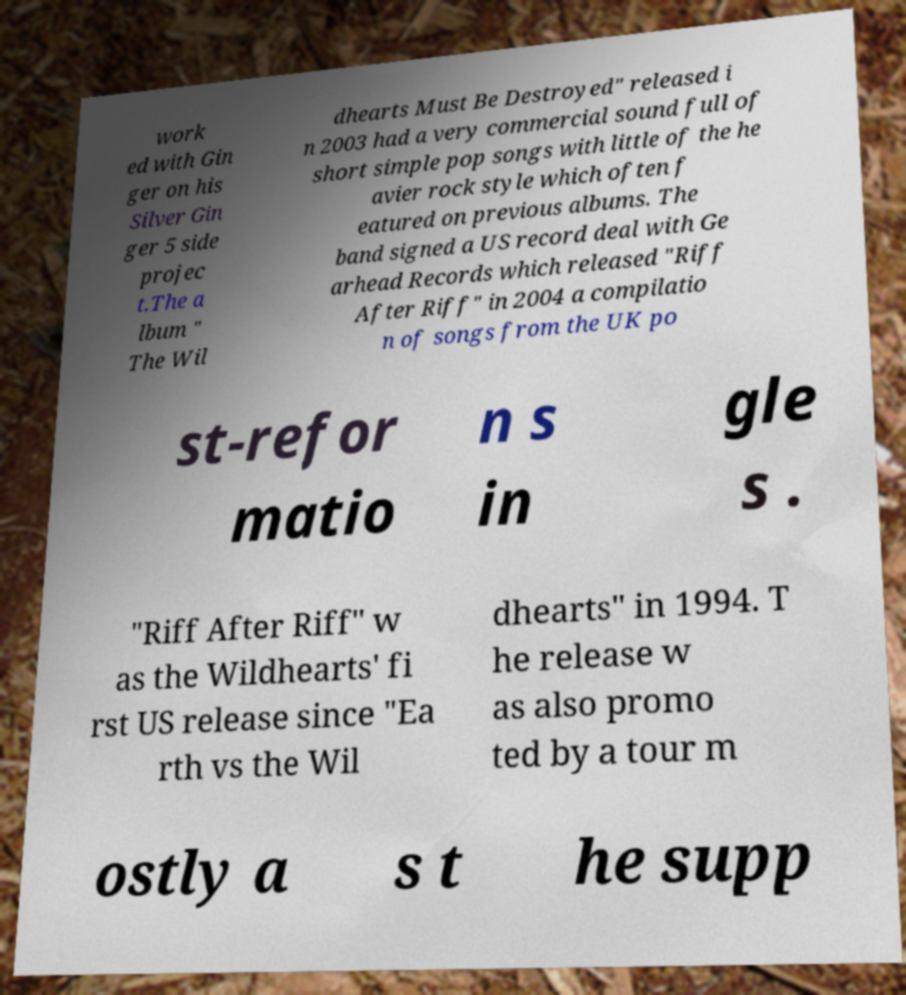Could you extract and type out the text from this image? work ed with Gin ger on his Silver Gin ger 5 side projec t.The a lbum " The Wil dhearts Must Be Destroyed" released i n 2003 had a very commercial sound full of short simple pop songs with little of the he avier rock style which often f eatured on previous albums. The band signed a US record deal with Ge arhead Records which released "Riff After Riff" in 2004 a compilatio n of songs from the UK po st-refor matio n s in gle s . "Riff After Riff" w as the Wildhearts' fi rst US release since "Ea rth vs the Wil dhearts" in 1994. T he release w as also promo ted by a tour m ostly a s t he supp 